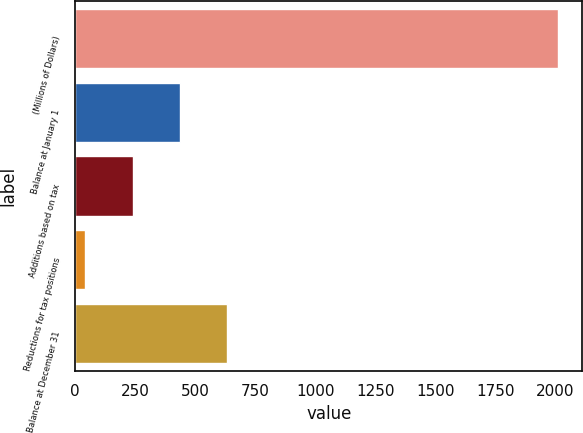Convert chart to OTSL. <chart><loc_0><loc_0><loc_500><loc_500><bar_chart><fcel>(Millions of Dollars)<fcel>Balance at January 1<fcel>Additions based on tax<fcel>Reductions for tax positions<fcel>Balance at December 31<nl><fcel>2011<fcel>435.8<fcel>238.9<fcel>42<fcel>632.7<nl></chart> 